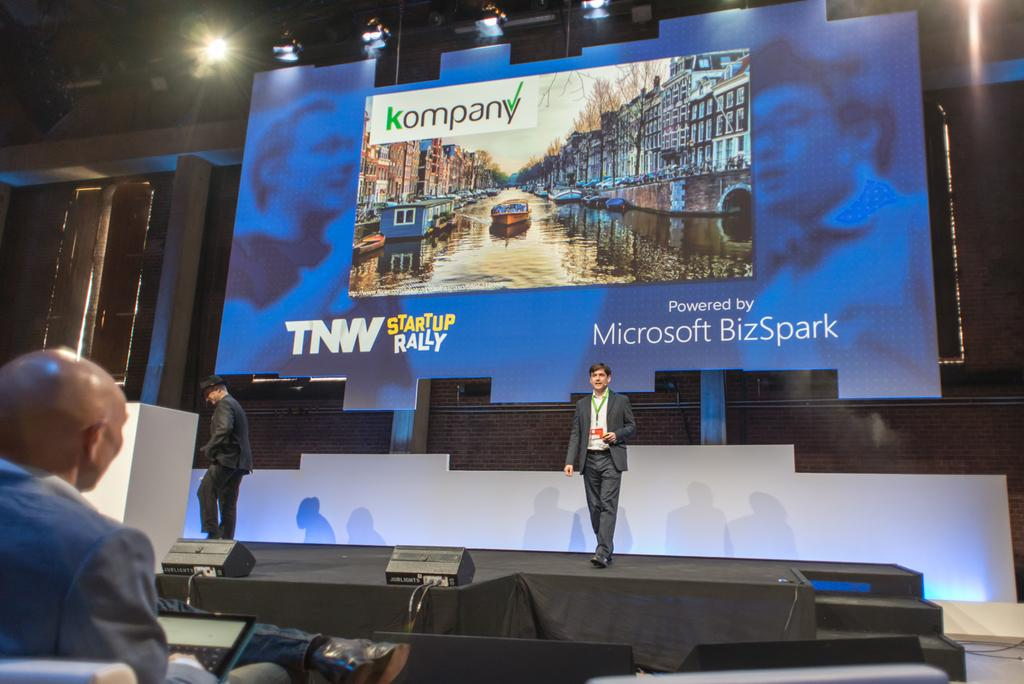<image>
Summarize the visual content of the image. a sign that says Microsoft on it with a man in front of it 